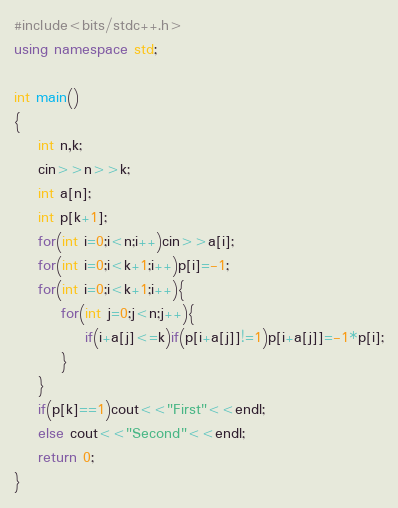<code> <loc_0><loc_0><loc_500><loc_500><_C++_>#include<bits/stdc++.h>
using namespace std;
 
int main()
{
    int n,k;
    cin>>n>>k;
    int a[n];
    int p[k+1];
    for(int i=0;i<n;i++)cin>>a[i];
    for(int i=0;i<k+1;i++)p[i]=-1;
    for(int i=0;i<k+1;i++){
        for(int j=0;j<n;j++){
            if(i+a[j]<=k)if(p[i+a[j]]!=1)p[i+a[j]]=-1*p[i];
        }
    }
    if(p[k]==1)cout<<"First"<<endl;
    else cout<<"Second"<<endl;
	return 0;
}</code> 